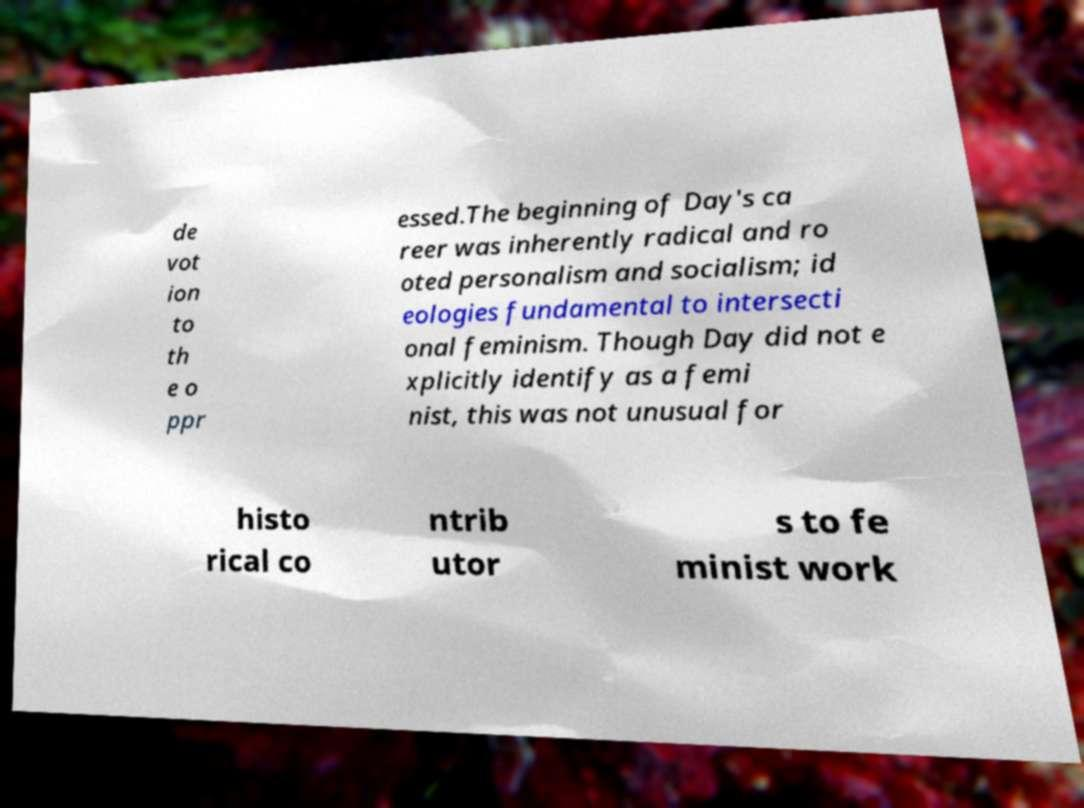There's text embedded in this image that I need extracted. Can you transcribe it verbatim? de vot ion to th e o ppr essed.The beginning of Day's ca reer was inherently radical and ro oted personalism and socialism; id eologies fundamental to intersecti onal feminism. Though Day did not e xplicitly identify as a femi nist, this was not unusual for histo rical co ntrib utor s to fe minist work 